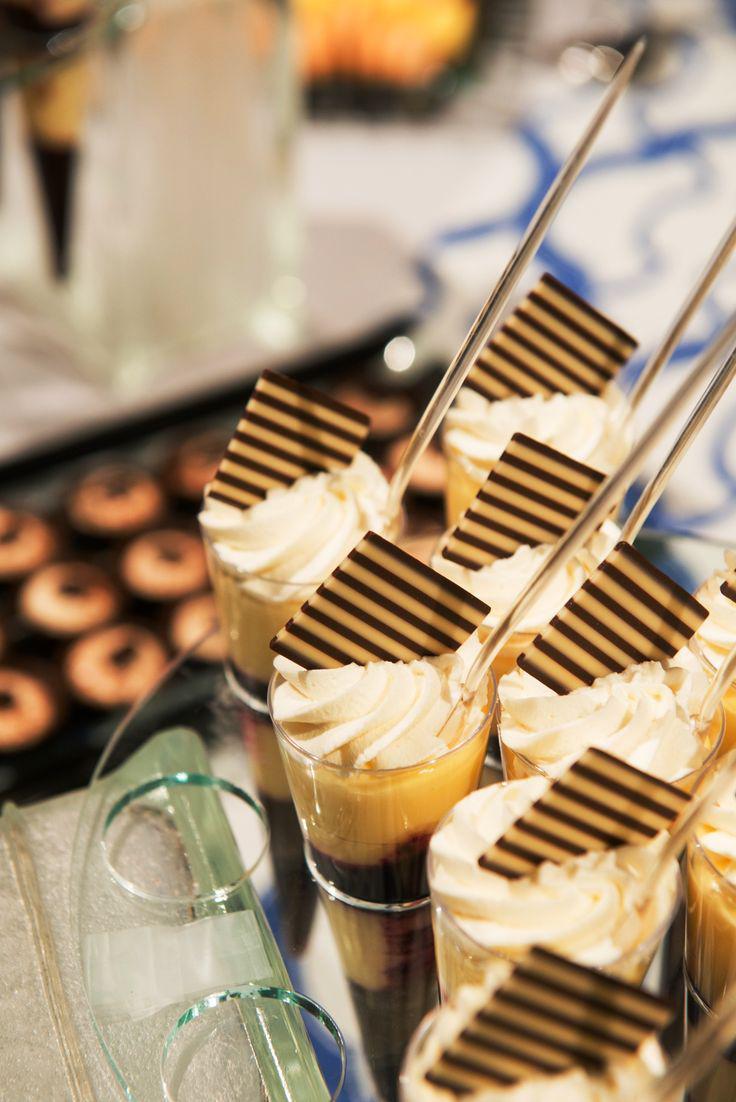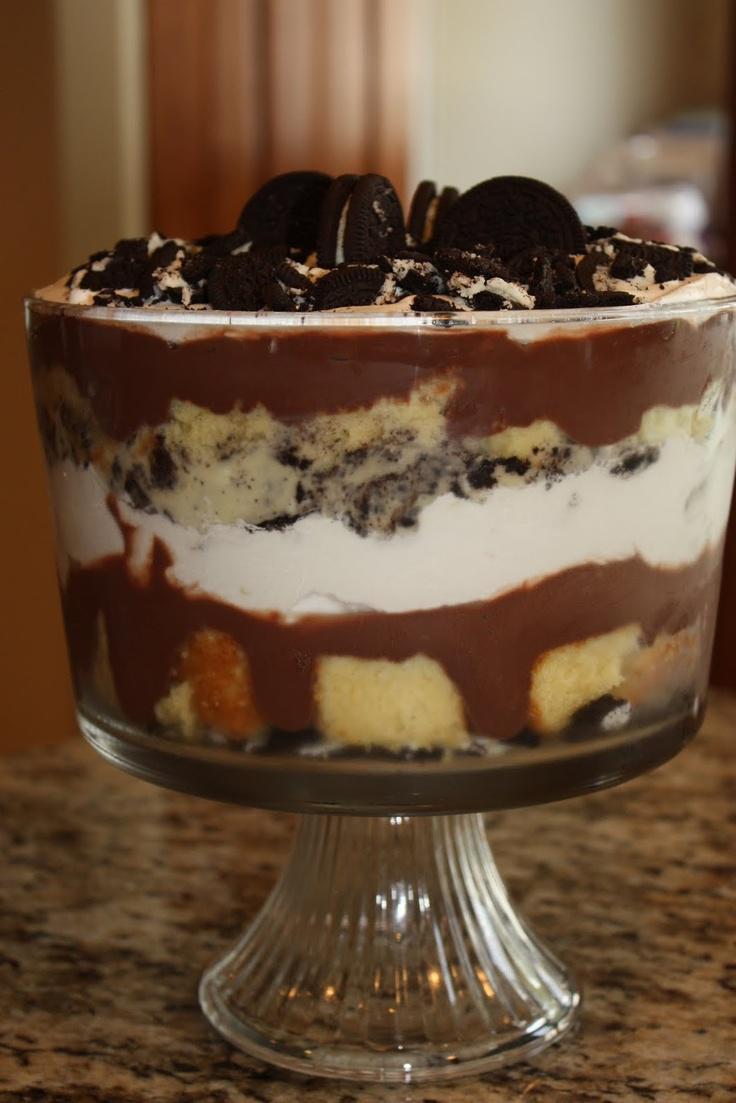The first image is the image on the left, the second image is the image on the right. Considering the images on both sides, is "Two large trifle desserts are made in clear bowls with chocolate and creamy layers, ending with garnished creamy topping." valid? Answer yes or no. No. 